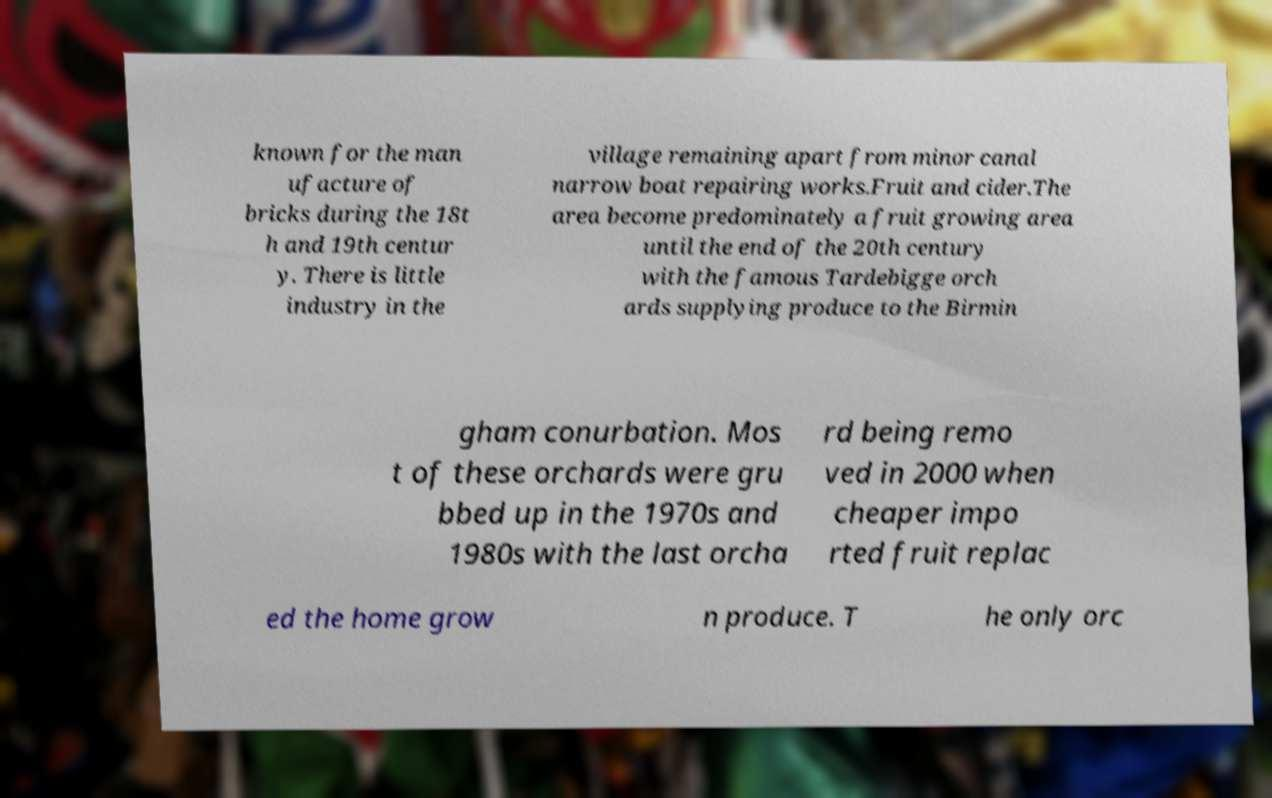Please identify and transcribe the text found in this image. known for the man ufacture of bricks during the 18t h and 19th centur y. There is little industry in the village remaining apart from minor canal narrow boat repairing works.Fruit and cider.The area become predominately a fruit growing area until the end of the 20th century with the famous Tardebigge orch ards supplying produce to the Birmin gham conurbation. Mos t of these orchards were gru bbed up in the 1970s and 1980s with the last orcha rd being remo ved in 2000 when cheaper impo rted fruit replac ed the home grow n produce. T he only orc 